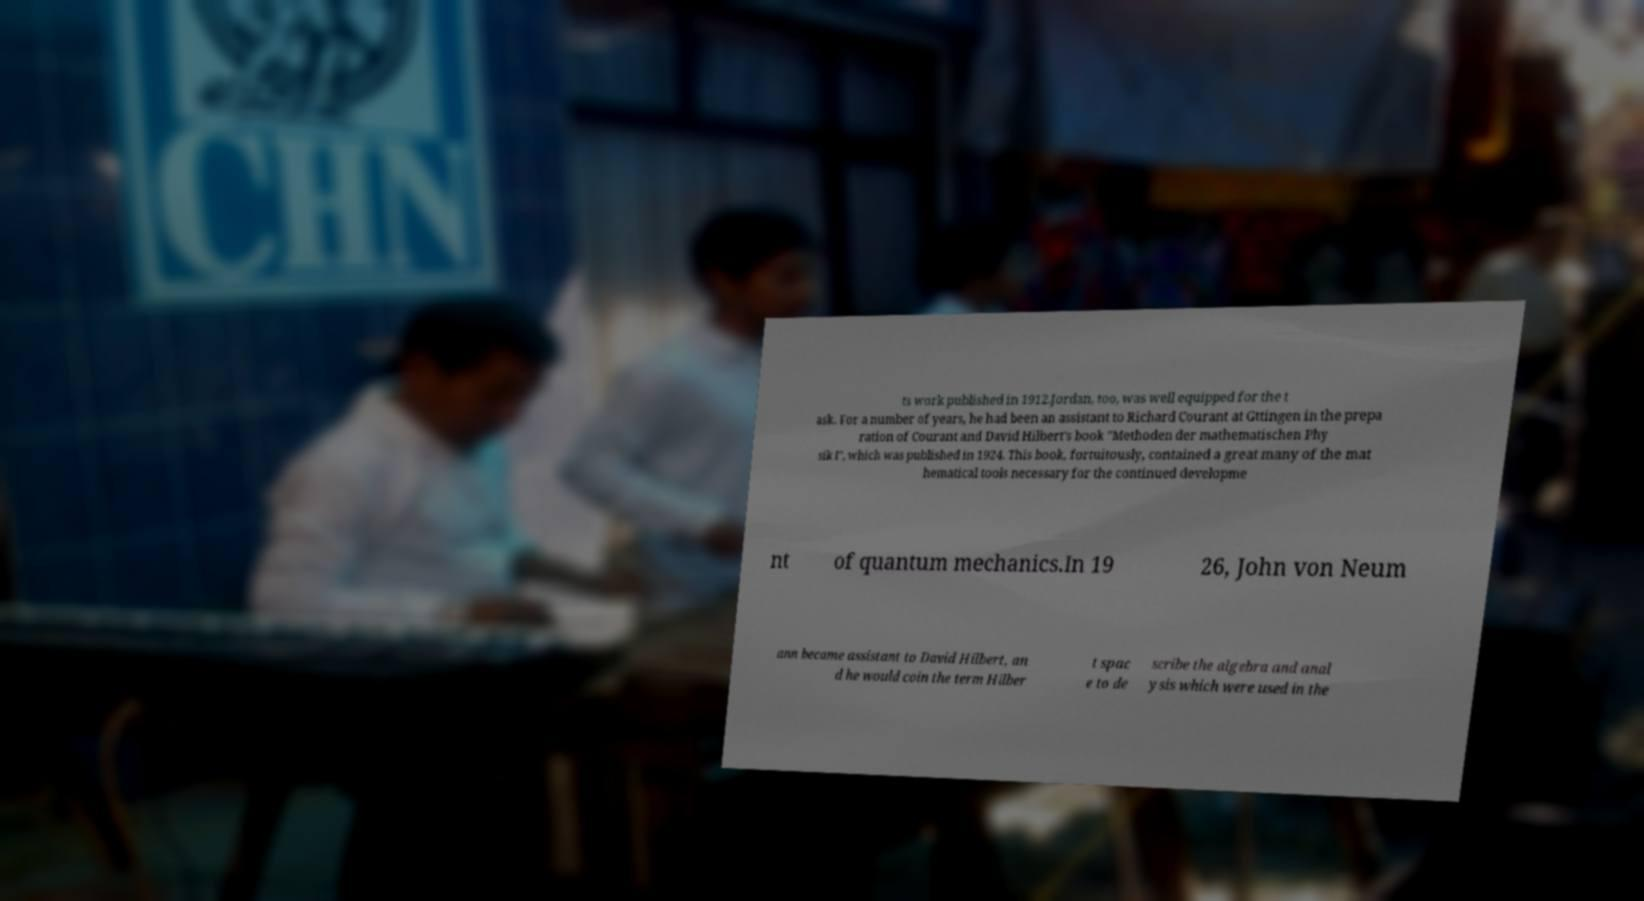Please read and relay the text visible in this image. What does it say? ts work published in 1912.Jordan, too, was well equipped for the t ask. For a number of years, he had been an assistant to Richard Courant at Gttingen in the prepa ration of Courant and David Hilbert's book "Methoden der mathematischen Phy sik I", which was published in 1924. This book, fortuitously, contained a great many of the mat hematical tools necessary for the continued developme nt of quantum mechanics.In 19 26, John von Neum ann became assistant to David Hilbert, an d he would coin the term Hilber t spac e to de scribe the algebra and anal ysis which were used in the 